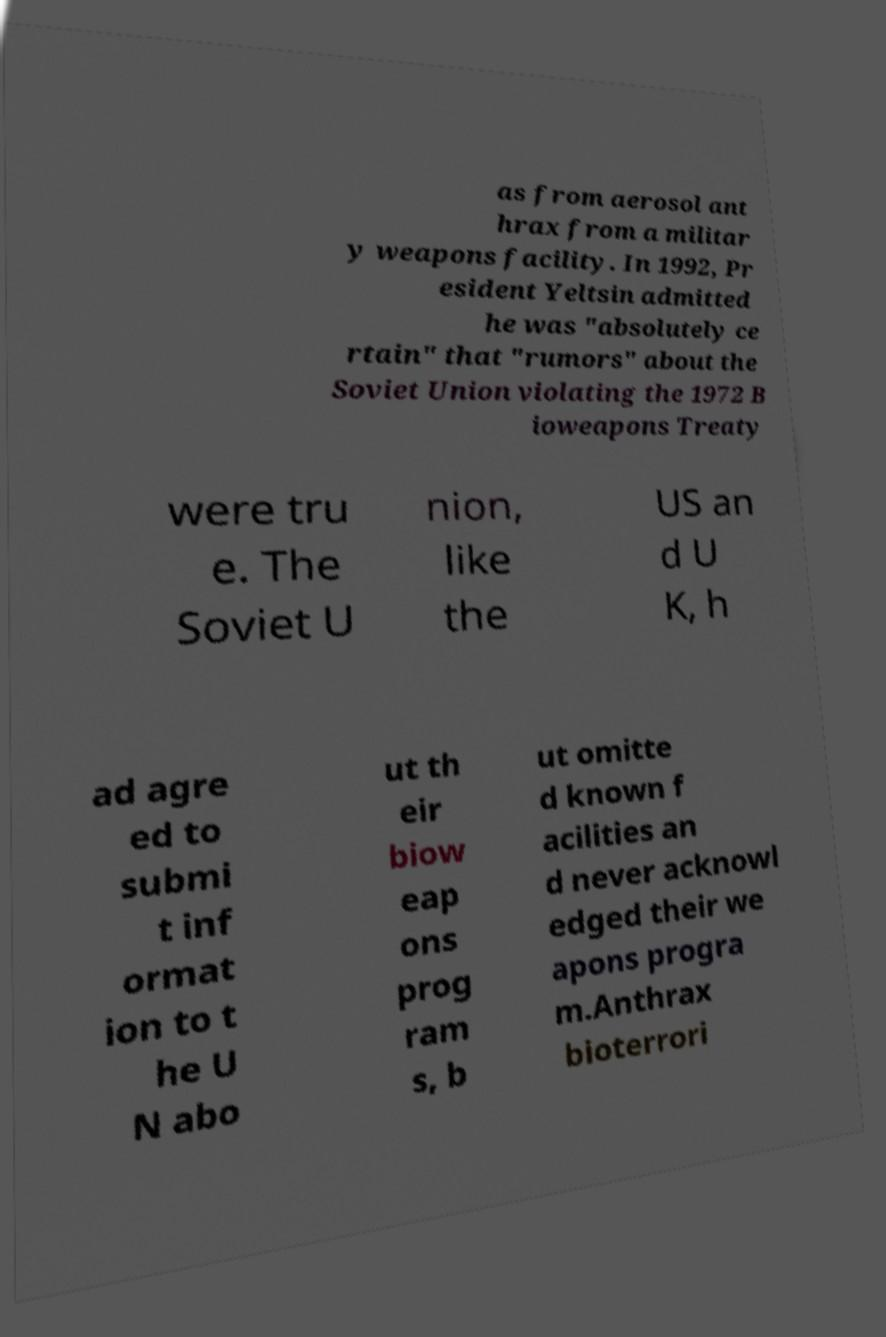Can you read and provide the text displayed in the image?This photo seems to have some interesting text. Can you extract and type it out for me? as from aerosol ant hrax from a militar y weapons facility. In 1992, Pr esident Yeltsin admitted he was "absolutely ce rtain" that "rumors" about the Soviet Union violating the 1972 B ioweapons Treaty were tru e. The Soviet U nion, like the US an d U K, h ad agre ed to submi t inf ormat ion to t he U N abo ut th eir biow eap ons prog ram s, b ut omitte d known f acilities an d never acknowl edged their we apons progra m.Anthrax bioterrori 